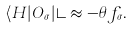Convert formula to latex. <formula><loc_0><loc_0><loc_500><loc_500>\langle H | O _ { \sigma } | \rangle \approx - \theta f _ { \sigma } .</formula> 